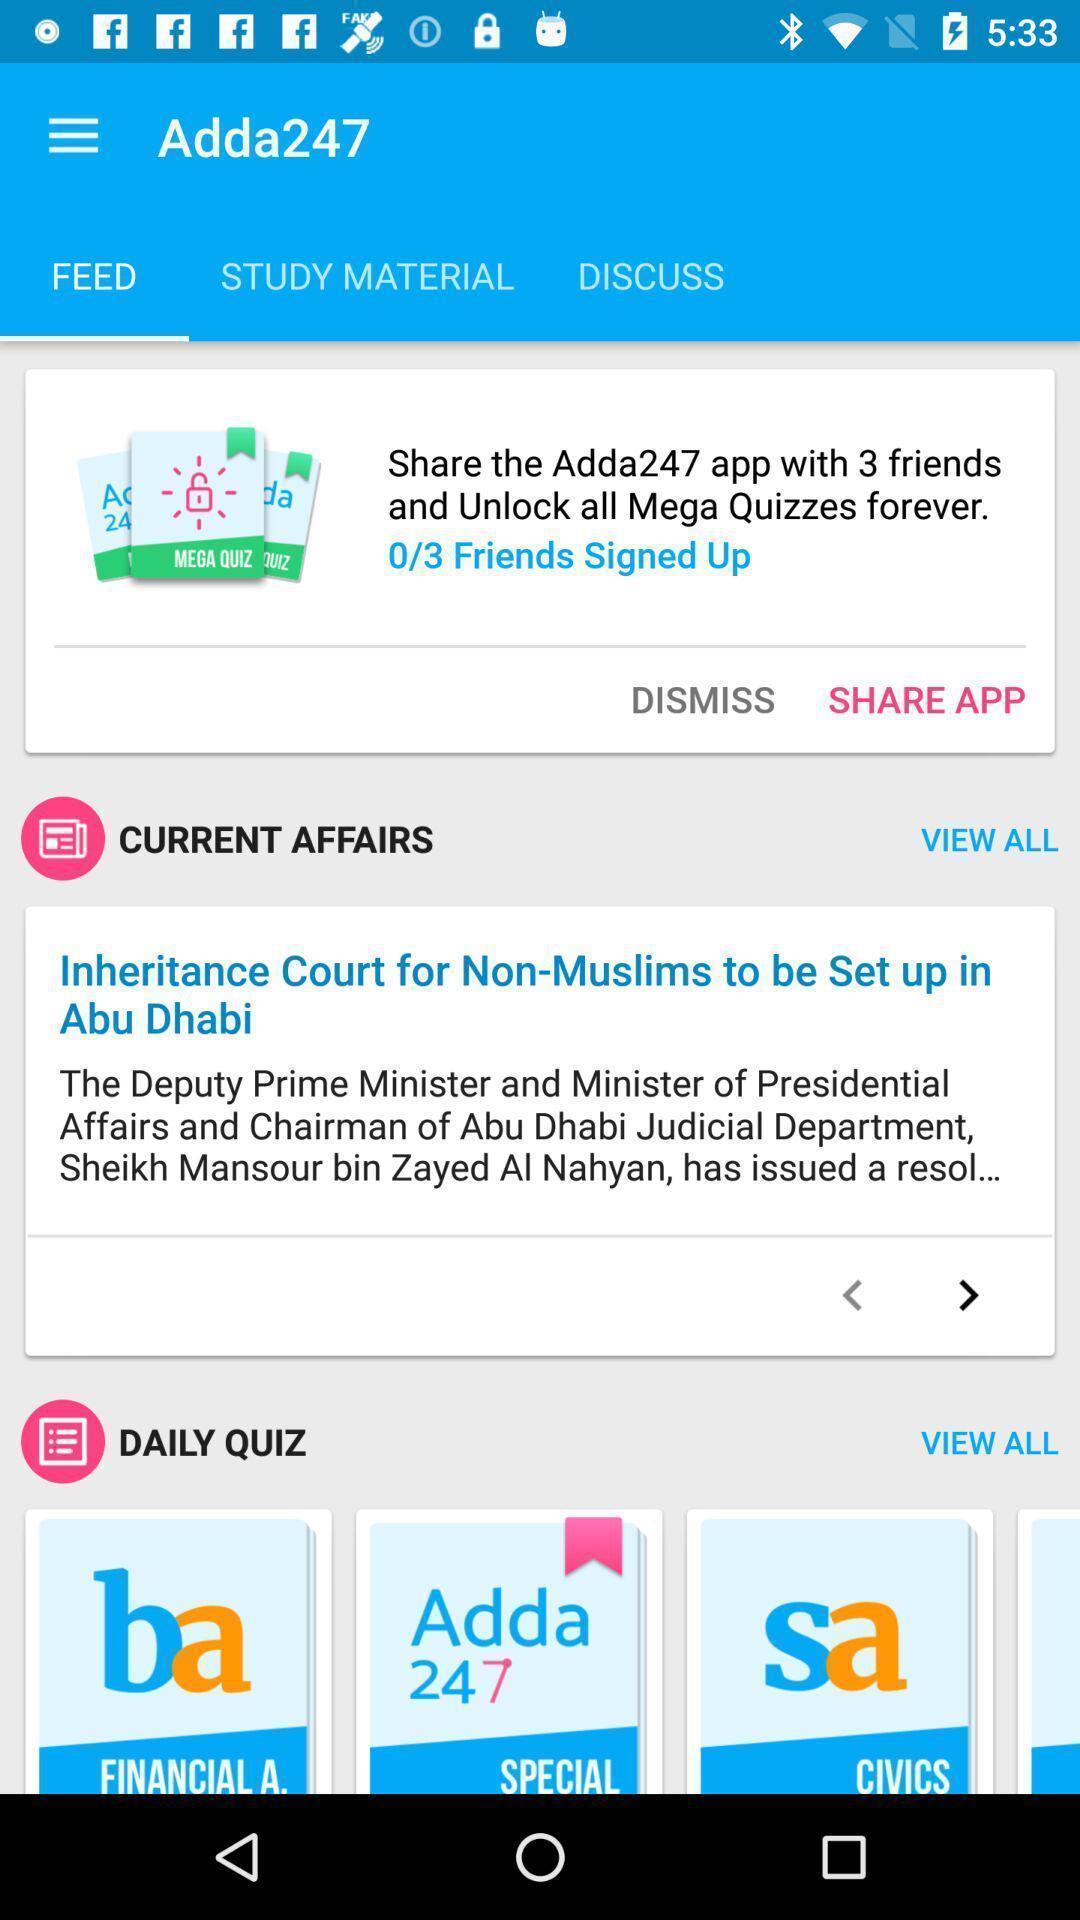Provide a detailed account of this screenshot. Page showing current affairs and daily quiz available. 